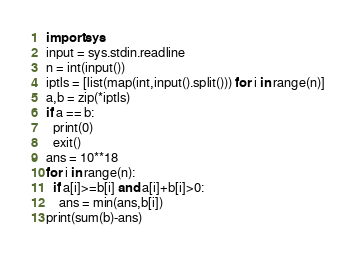<code> <loc_0><loc_0><loc_500><loc_500><_Python_>import sys
input = sys.stdin.readline
n = int(input())
iptls = [list(map(int,input().split())) for i in range(n)]
a,b = zip(*iptls)
if a == b:
  print(0)
  exit()
ans = 10**18
for i in range(n):
  if a[i]>=b[i] and a[i]+b[i]>0:
    ans = min(ans,b[i])
print(sum(b)-ans)</code> 